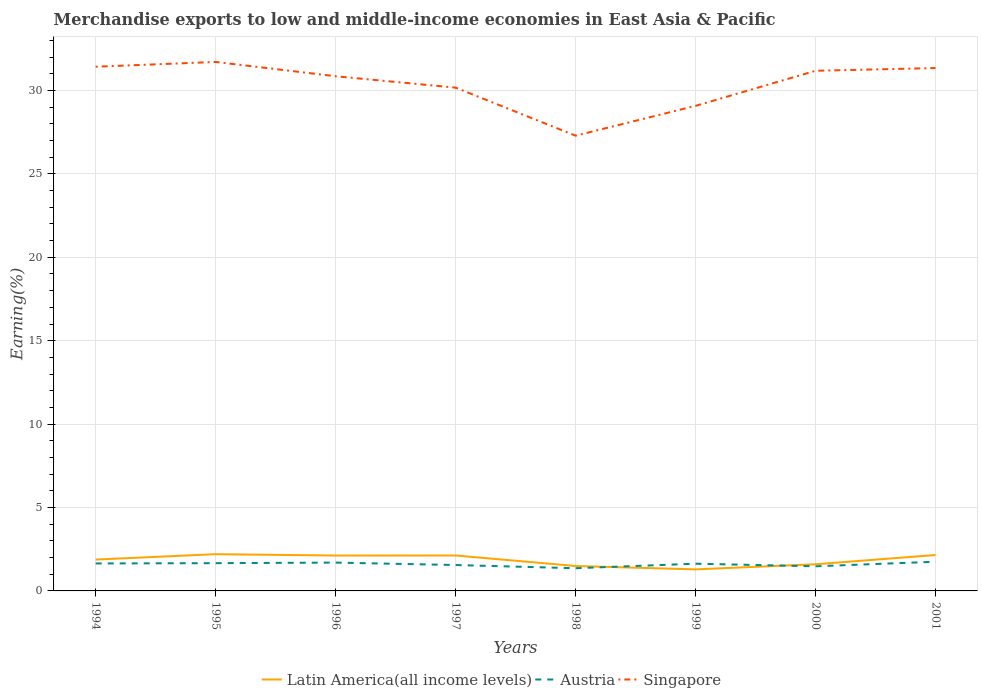How many different coloured lines are there?
Make the answer very short. 3. Does the line corresponding to Singapore intersect with the line corresponding to Austria?
Give a very brief answer. No. Is the number of lines equal to the number of legend labels?
Your response must be concise. Yes. Across all years, what is the maximum percentage of amount earned from merchandise exports in Latin America(all income levels)?
Keep it short and to the point. 1.29. What is the total percentage of amount earned from merchandise exports in Austria in the graph?
Offer a terse response. 0.34. What is the difference between the highest and the second highest percentage of amount earned from merchandise exports in Austria?
Offer a very short reply. 0.39. What is the difference between the highest and the lowest percentage of amount earned from merchandise exports in Latin America(all income levels)?
Offer a terse response. 5. How many lines are there?
Your answer should be compact. 3. How many years are there in the graph?
Ensure brevity in your answer.  8. Does the graph contain grids?
Your response must be concise. Yes. Where does the legend appear in the graph?
Keep it short and to the point. Bottom center. How many legend labels are there?
Make the answer very short. 3. What is the title of the graph?
Keep it short and to the point. Merchandise exports to low and middle-income economies in East Asia & Pacific. Does "Hong Kong" appear as one of the legend labels in the graph?
Offer a very short reply. No. What is the label or title of the Y-axis?
Your answer should be compact. Earning(%). What is the Earning(%) in Latin America(all income levels) in 1994?
Give a very brief answer. 1.88. What is the Earning(%) in Austria in 1994?
Give a very brief answer. 1.65. What is the Earning(%) of Singapore in 1994?
Make the answer very short. 31.42. What is the Earning(%) of Latin America(all income levels) in 1995?
Offer a terse response. 2.2. What is the Earning(%) of Austria in 1995?
Give a very brief answer. 1.66. What is the Earning(%) of Singapore in 1995?
Keep it short and to the point. 31.71. What is the Earning(%) in Latin America(all income levels) in 1996?
Offer a very short reply. 2.12. What is the Earning(%) of Austria in 1996?
Keep it short and to the point. 1.7. What is the Earning(%) of Singapore in 1996?
Your response must be concise. 30.85. What is the Earning(%) in Latin America(all income levels) in 1997?
Offer a terse response. 2.12. What is the Earning(%) of Austria in 1997?
Your response must be concise. 1.55. What is the Earning(%) of Singapore in 1997?
Give a very brief answer. 30.17. What is the Earning(%) in Latin America(all income levels) in 1998?
Offer a very short reply. 1.49. What is the Earning(%) of Austria in 1998?
Provide a succinct answer. 1.36. What is the Earning(%) of Singapore in 1998?
Provide a short and direct response. 27.29. What is the Earning(%) of Latin America(all income levels) in 1999?
Ensure brevity in your answer.  1.29. What is the Earning(%) of Austria in 1999?
Your answer should be compact. 1.63. What is the Earning(%) of Singapore in 1999?
Ensure brevity in your answer.  29.08. What is the Earning(%) in Latin America(all income levels) in 2000?
Make the answer very short. 1.6. What is the Earning(%) in Austria in 2000?
Your answer should be compact. 1.48. What is the Earning(%) in Singapore in 2000?
Your response must be concise. 31.18. What is the Earning(%) of Latin America(all income levels) in 2001?
Provide a succinct answer. 2.15. What is the Earning(%) in Austria in 2001?
Offer a terse response. 1.75. What is the Earning(%) of Singapore in 2001?
Your answer should be compact. 31.34. Across all years, what is the maximum Earning(%) in Latin America(all income levels)?
Give a very brief answer. 2.2. Across all years, what is the maximum Earning(%) of Austria?
Your response must be concise. 1.75. Across all years, what is the maximum Earning(%) in Singapore?
Offer a terse response. 31.71. Across all years, what is the minimum Earning(%) in Latin America(all income levels)?
Provide a succinct answer. 1.29. Across all years, what is the minimum Earning(%) in Austria?
Ensure brevity in your answer.  1.36. Across all years, what is the minimum Earning(%) in Singapore?
Provide a short and direct response. 27.29. What is the total Earning(%) of Latin America(all income levels) in the graph?
Give a very brief answer. 14.86. What is the total Earning(%) of Austria in the graph?
Ensure brevity in your answer.  12.78. What is the total Earning(%) in Singapore in the graph?
Your answer should be compact. 243.04. What is the difference between the Earning(%) of Latin America(all income levels) in 1994 and that in 1995?
Make the answer very short. -0.32. What is the difference between the Earning(%) of Austria in 1994 and that in 1995?
Offer a very short reply. -0.02. What is the difference between the Earning(%) of Singapore in 1994 and that in 1995?
Ensure brevity in your answer.  -0.29. What is the difference between the Earning(%) in Latin America(all income levels) in 1994 and that in 1996?
Ensure brevity in your answer.  -0.24. What is the difference between the Earning(%) in Austria in 1994 and that in 1996?
Give a very brief answer. -0.05. What is the difference between the Earning(%) in Singapore in 1994 and that in 1996?
Give a very brief answer. 0.57. What is the difference between the Earning(%) in Latin America(all income levels) in 1994 and that in 1997?
Keep it short and to the point. -0.24. What is the difference between the Earning(%) in Austria in 1994 and that in 1997?
Provide a short and direct response. 0.09. What is the difference between the Earning(%) in Singapore in 1994 and that in 1997?
Your answer should be compact. 1.25. What is the difference between the Earning(%) in Latin America(all income levels) in 1994 and that in 1998?
Provide a succinct answer. 0.39. What is the difference between the Earning(%) in Austria in 1994 and that in 1998?
Your answer should be compact. 0.29. What is the difference between the Earning(%) in Singapore in 1994 and that in 1998?
Provide a short and direct response. 4.13. What is the difference between the Earning(%) of Latin America(all income levels) in 1994 and that in 1999?
Offer a very short reply. 0.59. What is the difference between the Earning(%) of Austria in 1994 and that in 1999?
Keep it short and to the point. 0.01. What is the difference between the Earning(%) of Singapore in 1994 and that in 1999?
Offer a very short reply. 2.35. What is the difference between the Earning(%) in Latin America(all income levels) in 1994 and that in 2000?
Offer a very short reply. 0.28. What is the difference between the Earning(%) of Austria in 1994 and that in 2000?
Make the answer very short. 0.17. What is the difference between the Earning(%) of Singapore in 1994 and that in 2000?
Offer a very short reply. 0.24. What is the difference between the Earning(%) in Latin America(all income levels) in 1994 and that in 2001?
Offer a very short reply. -0.27. What is the difference between the Earning(%) of Austria in 1994 and that in 2001?
Provide a succinct answer. -0.1. What is the difference between the Earning(%) of Latin America(all income levels) in 1995 and that in 1996?
Provide a succinct answer. 0.08. What is the difference between the Earning(%) in Austria in 1995 and that in 1996?
Provide a succinct answer. -0.03. What is the difference between the Earning(%) of Singapore in 1995 and that in 1996?
Provide a succinct answer. 0.86. What is the difference between the Earning(%) in Latin America(all income levels) in 1995 and that in 1997?
Provide a succinct answer. 0.08. What is the difference between the Earning(%) in Austria in 1995 and that in 1997?
Provide a succinct answer. 0.11. What is the difference between the Earning(%) in Singapore in 1995 and that in 1997?
Your answer should be very brief. 1.54. What is the difference between the Earning(%) in Latin America(all income levels) in 1995 and that in 1998?
Make the answer very short. 0.71. What is the difference between the Earning(%) of Austria in 1995 and that in 1998?
Provide a short and direct response. 0.3. What is the difference between the Earning(%) in Singapore in 1995 and that in 1998?
Offer a very short reply. 4.42. What is the difference between the Earning(%) of Latin America(all income levels) in 1995 and that in 1999?
Provide a short and direct response. 0.91. What is the difference between the Earning(%) of Austria in 1995 and that in 1999?
Offer a terse response. 0.03. What is the difference between the Earning(%) in Singapore in 1995 and that in 1999?
Your answer should be compact. 2.63. What is the difference between the Earning(%) in Latin America(all income levels) in 1995 and that in 2000?
Provide a succinct answer. 0.6. What is the difference between the Earning(%) of Austria in 1995 and that in 2000?
Give a very brief answer. 0.19. What is the difference between the Earning(%) of Singapore in 1995 and that in 2000?
Keep it short and to the point. 0.53. What is the difference between the Earning(%) in Latin America(all income levels) in 1995 and that in 2001?
Your response must be concise. 0.05. What is the difference between the Earning(%) in Austria in 1995 and that in 2001?
Provide a succinct answer. -0.09. What is the difference between the Earning(%) in Singapore in 1995 and that in 2001?
Keep it short and to the point. 0.37. What is the difference between the Earning(%) in Latin America(all income levels) in 1996 and that in 1997?
Offer a terse response. -0. What is the difference between the Earning(%) of Austria in 1996 and that in 1997?
Offer a terse response. 0.15. What is the difference between the Earning(%) of Singapore in 1996 and that in 1997?
Offer a terse response. 0.68. What is the difference between the Earning(%) in Latin America(all income levels) in 1996 and that in 1998?
Give a very brief answer. 0.63. What is the difference between the Earning(%) of Austria in 1996 and that in 1998?
Provide a short and direct response. 0.34. What is the difference between the Earning(%) in Singapore in 1996 and that in 1998?
Offer a very short reply. 3.56. What is the difference between the Earning(%) in Latin America(all income levels) in 1996 and that in 1999?
Your answer should be very brief. 0.83. What is the difference between the Earning(%) of Austria in 1996 and that in 1999?
Your answer should be very brief. 0.07. What is the difference between the Earning(%) of Singapore in 1996 and that in 1999?
Offer a very short reply. 1.77. What is the difference between the Earning(%) in Latin America(all income levels) in 1996 and that in 2000?
Your response must be concise. 0.52. What is the difference between the Earning(%) in Austria in 1996 and that in 2000?
Give a very brief answer. 0.22. What is the difference between the Earning(%) in Singapore in 1996 and that in 2000?
Keep it short and to the point. -0.33. What is the difference between the Earning(%) of Latin America(all income levels) in 1996 and that in 2001?
Ensure brevity in your answer.  -0.03. What is the difference between the Earning(%) in Austria in 1996 and that in 2001?
Your answer should be compact. -0.05. What is the difference between the Earning(%) in Singapore in 1996 and that in 2001?
Offer a terse response. -0.49. What is the difference between the Earning(%) in Latin America(all income levels) in 1997 and that in 1998?
Offer a very short reply. 0.63. What is the difference between the Earning(%) in Austria in 1997 and that in 1998?
Provide a succinct answer. 0.19. What is the difference between the Earning(%) of Singapore in 1997 and that in 1998?
Provide a succinct answer. 2.88. What is the difference between the Earning(%) in Latin America(all income levels) in 1997 and that in 1999?
Give a very brief answer. 0.83. What is the difference between the Earning(%) in Austria in 1997 and that in 1999?
Provide a short and direct response. -0.08. What is the difference between the Earning(%) in Singapore in 1997 and that in 1999?
Your answer should be very brief. 1.09. What is the difference between the Earning(%) of Latin America(all income levels) in 1997 and that in 2000?
Offer a terse response. 0.53. What is the difference between the Earning(%) of Austria in 1997 and that in 2000?
Your response must be concise. 0.08. What is the difference between the Earning(%) in Singapore in 1997 and that in 2000?
Make the answer very short. -1.01. What is the difference between the Earning(%) of Latin America(all income levels) in 1997 and that in 2001?
Keep it short and to the point. -0.03. What is the difference between the Earning(%) in Austria in 1997 and that in 2001?
Your answer should be compact. -0.2. What is the difference between the Earning(%) of Singapore in 1997 and that in 2001?
Ensure brevity in your answer.  -1.17. What is the difference between the Earning(%) in Latin America(all income levels) in 1998 and that in 1999?
Give a very brief answer. 0.2. What is the difference between the Earning(%) of Austria in 1998 and that in 1999?
Offer a very short reply. -0.27. What is the difference between the Earning(%) in Singapore in 1998 and that in 1999?
Make the answer very short. -1.79. What is the difference between the Earning(%) of Latin America(all income levels) in 1998 and that in 2000?
Give a very brief answer. -0.11. What is the difference between the Earning(%) in Austria in 1998 and that in 2000?
Your response must be concise. -0.12. What is the difference between the Earning(%) of Singapore in 1998 and that in 2000?
Your answer should be very brief. -3.89. What is the difference between the Earning(%) of Latin America(all income levels) in 1998 and that in 2001?
Make the answer very short. -0.66. What is the difference between the Earning(%) of Austria in 1998 and that in 2001?
Make the answer very short. -0.39. What is the difference between the Earning(%) in Singapore in 1998 and that in 2001?
Your response must be concise. -4.05. What is the difference between the Earning(%) in Latin America(all income levels) in 1999 and that in 2000?
Your answer should be compact. -0.31. What is the difference between the Earning(%) in Austria in 1999 and that in 2000?
Your answer should be compact. 0.16. What is the difference between the Earning(%) of Singapore in 1999 and that in 2000?
Your answer should be very brief. -2.1. What is the difference between the Earning(%) in Latin America(all income levels) in 1999 and that in 2001?
Your answer should be very brief. -0.86. What is the difference between the Earning(%) of Austria in 1999 and that in 2001?
Offer a very short reply. -0.12. What is the difference between the Earning(%) of Singapore in 1999 and that in 2001?
Give a very brief answer. -2.27. What is the difference between the Earning(%) of Latin America(all income levels) in 2000 and that in 2001?
Your answer should be very brief. -0.55. What is the difference between the Earning(%) in Austria in 2000 and that in 2001?
Give a very brief answer. -0.27. What is the difference between the Earning(%) of Singapore in 2000 and that in 2001?
Keep it short and to the point. -0.16. What is the difference between the Earning(%) of Latin America(all income levels) in 1994 and the Earning(%) of Austria in 1995?
Make the answer very short. 0.22. What is the difference between the Earning(%) of Latin America(all income levels) in 1994 and the Earning(%) of Singapore in 1995?
Your response must be concise. -29.83. What is the difference between the Earning(%) of Austria in 1994 and the Earning(%) of Singapore in 1995?
Keep it short and to the point. -30.06. What is the difference between the Earning(%) in Latin America(all income levels) in 1994 and the Earning(%) in Austria in 1996?
Keep it short and to the point. 0.18. What is the difference between the Earning(%) of Latin America(all income levels) in 1994 and the Earning(%) of Singapore in 1996?
Offer a very short reply. -28.97. What is the difference between the Earning(%) in Austria in 1994 and the Earning(%) in Singapore in 1996?
Your answer should be compact. -29.2. What is the difference between the Earning(%) in Latin America(all income levels) in 1994 and the Earning(%) in Austria in 1997?
Make the answer very short. 0.33. What is the difference between the Earning(%) of Latin America(all income levels) in 1994 and the Earning(%) of Singapore in 1997?
Give a very brief answer. -28.29. What is the difference between the Earning(%) of Austria in 1994 and the Earning(%) of Singapore in 1997?
Ensure brevity in your answer.  -28.52. What is the difference between the Earning(%) of Latin America(all income levels) in 1994 and the Earning(%) of Austria in 1998?
Make the answer very short. 0.52. What is the difference between the Earning(%) in Latin America(all income levels) in 1994 and the Earning(%) in Singapore in 1998?
Offer a very short reply. -25.41. What is the difference between the Earning(%) of Austria in 1994 and the Earning(%) of Singapore in 1998?
Offer a terse response. -25.64. What is the difference between the Earning(%) in Latin America(all income levels) in 1994 and the Earning(%) in Austria in 1999?
Your response must be concise. 0.25. What is the difference between the Earning(%) in Latin America(all income levels) in 1994 and the Earning(%) in Singapore in 1999?
Make the answer very short. -27.2. What is the difference between the Earning(%) in Austria in 1994 and the Earning(%) in Singapore in 1999?
Provide a short and direct response. -27.43. What is the difference between the Earning(%) in Latin America(all income levels) in 1994 and the Earning(%) in Austria in 2000?
Offer a terse response. 0.4. What is the difference between the Earning(%) of Latin America(all income levels) in 1994 and the Earning(%) of Singapore in 2000?
Make the answer very short. -29.3. What is the difference between the Earning(%) in Austria in 1994 and the Earning(%) in Singapore in 2000?
Offer a very short reply. -29.53. What is the difference between the Earning(%) in Latin America(all income levels) in 1994 and the Earning(%) in Austria in 2001?
Offer a very short reply. 0.13. What is the difference between the Earning(%) in Latin America(all income levels) in 1994 and the Earning(%) in Singapore in 2001?
Your answer should be compact. -29.46. What is the difference between the Earning(%) of Austria in 1994 and the Earning(%) of Singapore in 2001?
Provide a succinct answer. -29.7. What is the difference between the Earning(%) in Latin America(all income levels) in 1995 and the Earning(%) in Austria in 1996?
Your answer should be compact. 0.5. What is the difference between the Earning(%) in Latin America(all income levels) in 1995 and the Earning(%) in Singapore in 1996?
Provide a short and direct response. -28.65. What is the difference between the Earning(%) of Austria in 1995 and the Earning(%) of Singapore in 1996?
Provide a short and direct response. -29.19. What is the difference between the Earning(%) of Latin America(all income levels) in 1995 and the Earning(%) of Austria in 1997?
Offer a terse response. 0.65. What is the difference between the Earning(%) of Latin America(all income levels) in 1995 and the Earning(%) of Singapore in 1997?
Your response must be concise. -27.97. What is the difference between the Earning(%) of Austria in 1995 and the Earning(%) of Singapore in 1997?
Make the answer very short. -28.5. What is the difference between the Earning(%) of Latin America(all income levels) in 1995 and the Earning(%) of Austria in 1998?
Your response must be concise. 0.84. What is the difference between the Earning(%) of Latin America(all income levels) in 1995 and the Earning(%) of Singapore in 1998?
Provide a succinct answer. -25.09. What is the difference between the Earning(%) of Austria in 1995 and the Earning(%) of Singapore in 1998?
Your answer should be compact. -25.62. What is the difference between the Earning(%) in Latin America(all income levels) in 1995 and the Earning(%) in Austria in 1999?
Keep it short and to the point. 0.57. What is the difference between the Earning(%) of Latin America(all income levels) in 1995 and the Earning(%) of Singapore in 1999?
Ensure brevity in your answer.  -26.87. What is the difference between the Earning(%) of Austria in 1995 and the Earning(%) of Singapore in 1999?
Provide a short and direct response. -27.41. What is the difference between the Earning(%) of Latin America(all income levels) in 1995 and the Earning(%) of Austria in 2000?
Keep it short and to the point. 0.73. What is the difference between the Earning(%) in Latin America(all income levels) in 1995 and the Earning(%) in Singapore in 2000?
Provide a succinct answer. -28.98. What is the difference between the Earning(%) of Austria in 1995 and the Earning(%) of Singapore in 2000?
Ensure brevity in your answer.  -29.52. What is the difference between the Earning(%) in Latin America(all income levels) in 1995 and the Earning(%) in Austria in 2001?
Your response must be concise. 0.45. What is the difference between the Earning(%) in Latin America(all income levels) in 1995 and the Earning(%) in Singapore in 2001?
Provide a short and direct response. -29.14. What is the difference between the Earning(%) in Austria in 1995 and the Earning(%) in Singapore in 2001?
Keep it short and to the point. -29.68. What is the difference between the Earning(%) in Latin America(all income levels) in 1996 and the Earning(%) in Austria in 1997?
Offer a terse response. 0.57. What is the difference between the Earning(%) of Latin America(all income levels) in 1996 and the Earning(%) of Singapore in 1997?
Your answer should be very brief. -28.05. What is the difference between the Earning(%) of Austria in 1996 and the Earning(%) of Singapore in 1997?
Your answer should be very brief. -28.47. What is the difference between the Earning(%) of Latin America(all income levels) in 1996 and the Earning(%) of Austria in 1998?
Keep it short and to the point. 0.76. What is the difference between the Earning(%) of Latin America(all income levels) in 1996 and the Earning(%) of Singapore in 1998?
Give a very brief answer. -25.17. What is the difference between the Earning(%) in Austria in 1996 and the Earning(%) in Singapore in 1998?
Provide a short and direct response. -25.59. What is the difference between the Earning(%) of Latin America(all income levels) in 1996 and the Earning(%) of Austria in 1999?
Provide a short and direct response. 0.49. What is the difference between the Earning(%) of Latin America(all income levels) in 1996 and the Earning(%) of Singapore in 1999?
Give a very brief answer. -26.95. What is the difference between the Earning(%) in Austria in 1996 and the Earning(%) in Singapore in 1999?
Offer a very short reply. -27.38. What is the difference between the Earning(%) in Latin America(all income levels) in 1996 and the Earning(%) in Austria in 2000?
Your response must be concise. 0.65. What is the difference between the Earning(%) of Latin America(all income levels) in 1996 and the Earning(%) of Singapore in 2000?
Your response must be concise. -29.06. What is the difference between the Earning(%) of Austria in 1996 and the Earning(%) of Singapore in 2000?
Your answer should be compact. -29.48. What is the difference between the Earning(%) of Latin America(all income levels) in 1996 and the Earning(%) of Austria in 2001?
Ensure brevity in your answer.  0.37. What is the difference between the Earning(%) in Latin America(all income levels) in 1996 and the Earning(%) in Singapore in 2001?
Your answer should be very brief. -29.22. What is the difference between the Earning(%) of Austria in 1996 and the Earning(%) of Singapore in 2001?
Provide a succinct answer. -29.64. What is the difference between the Earning(%) of Latin America(all income levels) in 1997 and the Earning(%) of Austria in 1998?
Keep it short and to the point. 0.76. What is the difference between the Earning(%) of Latin America(all income levels) in 1997 and the Earning(%) of Singapore in 1998?
Provide a short and direct response. -25.16. What is the difference between the Earning(%) in Austria in 1997 and the Earning(%) in Singapore in 1998?
Keep it short and to the point. -25.74. What is the difference between the Earning(%) of Latin America(all income levels) in 1997 and the Earning(%) of Austria in 1999?
Keep it short and to the point. 0.49. What is the difference between the Earning(%) of Latin America(all income levels) in 1997 and the Earning(%) of Singapore in 1999?
Your answer should be very brief. -26.95. What is the difference between the Earning(%) in Austria in 1997 and the Earning(%) in Singapore in 1999?
Offer a very short reply. -27.52. What is the difference between the Earning(%) in Latin America(all income levels) in 1997 and the Earning(%) in Austria in 2000?
Your answer should be very brief. 0.65. What is the difference between the Earning(%) in Latin America(all income levels) in 1997 and the Earning(%) in Singapore in 2000?
Your response must be concise. -29.05. What is the difference between the Earning(%) in Austria in 1997 and the Earning(%) in Singapore in 2000?
Your answer should be compact. -29.63. What is the difference between the Earning(%) of Latin America(all income levels) in 1997 and the Earning(%) of Austria in 2001?
Make the answer very short. 0.37. What is the difference between the Earning(%) in Latin America(all income levels) in 1997 and the Earning(%) in Singapore in 2001?
Ensure brevity in your answer.  -29.22. What is the difference between the Earning(%) of Austria in 1997 and the Earning(%) of Singapore in 2001?
Make the answer very short. -29.79. What is the difference between the Earning(%) in Latin America(all income levels) in 1998 and the Earning(%) in Austria in 1999?
Your answer should be compact. -0.14. What is the difference between the Earning(%) in Latin America(all income levels) in 1998 and the Earning(%) in Singapore in 1999?
Make the answer very short. -27.58. What is the difference between the Earning(%) in Austria in 1998 and the Earning(%) in Singapore in 1999?
Offer a terse response. -27.72. What is the difference between the Earning(%) in Latin America(all income levels) in 1998 and the Earning(%) in Austria in 2000?
Provide a short and direct response. 0.02. What is the difference between the Earning(%) in Latin America(all income levels) in 1998 and the Earning(%) in Singapore in 2000?
Offer a terse response. -29.69. What is the difference between the Earning(%) in Austria in 1998 and the Earning(%) in Singapore in 2000?
Your answer should be compact. -29.82. What is the difference between the Earning(%) in Latin America(all income levels) in 1998 and the Earning(%) in Austria in 2001?
Provide a succinct answer. -0.26. What is the difference between the Earning(%) of Latin America(all income levels) in 1998 and the Earning(%) of Singapore in 2001?
Offer a very short reply. -29.85. What is the difference between the Earning(%) in Austria in 1998 and the Earning(%) in Singapore in 2001?
Offer a terse response. -29.98. What is the difference between the Earning(%) of Latin America(all income levels) in 1999 and the Earning(%) of Austria in 2000?
Provide a succinct answer. -0.18. What is the difference between the Earning(%) in Latin America(all income levels) in 1999 and the Earning(%) in Singapore in 2000?
Make the answer very short. -29.89. What is the difference between the Earning(%) of Austria in 1999 and the Earning(%) of Singapore in 2000?
Your response must be concise. -29.55. What is the difference between the Earning(%) in Latin America(all income levels) in 1999 and the Earning(%) in Austria in 2001?
Offer a terse response. -0.46. What is the difference between the Earning(%) in Latin America(all income levels) in 1999 and the Earning(%) in Singapore in 2001?
Provide a short and direct response. -30.05. What is the difference between the Earning(%) of Austria in 1999 and the Earning(%) of Singapore in 2001?
Your response must be concise. -29.71. What is the difference between the Earning(%) in Latin America(all income levels) in 2000 and the Earning(%) in Austria in 2001?
Offer a very short reply. -0.15. What is the difference between the Earning(%) of Latin America(all income levels) in 2000 and the Earning(%) of Singapore in 2001?
Your answer should be very brief. -29.75. What is the difference between the Earning(%) of Austria in 2000 and the Earning(%) of Singapore in 2001?
Your answer should be compact. -29.87. What is the average Earning(%) in Latin America(all income levels) per year?
Your answer should be compact. 1.86. What is the average Earning(%) in Austria per year?
Keep it short and to the point. 1.6. What is the average Earning(%) of Singapore per year?
Your answer should be compact. 30.38. In the year 1994, what is the difference between the Earning(%) of Latin America(all income levels) and Earning(%) of Austria?
Keep it short and to the point. 0.23. In the year 1994, what is the difference between the Earning(%) in Latin America(all income levels) and Earning(%) in Singapore?
Offer a terse response. -29.54. In the year 1994, what is the difference between the Earning(%) of Austria and Earning(%) of Singapore?
Offer a terse response. -29.78. In the year 1995, what is the difference between the Earning(%) of Latin America(all income levels) and Earning(%) of Austria?
Offer a very short reply. 0.54. In the year 1995, what is the difference between the Earning(%) in Latin America(all income levels) and Earning(%) in Singapore?
Offer a very short reply. -29.51. In the year 1995, what is the difference between the Earning(%) in Austria and Earning(%) in Singapore?
Your answer should be very brief. -30.04. In the year 1996, what is the difference between the Earning(%) in Latin America(all income levels) and Earning(%) in Austria?
Offer a very short reply. 0.42. In the year 1996, what is the difference between the Earning(%) in Latin America(all income levels) and Earning(%) in Singapore?
Offer a very short reply. -28.73. In the year 1996, what is the difference between the Earning(%) of Austria and Earning(%) of Singapore?
Make the answer very short. -29.15. In the year 1997, what is the difference between the Earning(%) of Latin America(all income levels) and Earning(%) of Austria?
Give a very brief answer. 0.57. In the year 1997, what is the difference between the Earning(%) in Latin America(all income levels) and Earning(%) in Singapore?
Ensure brevity in your answer.  -28.04. In the year 1997, what is the difference between the Earning(%) in Austria and Earning(%) in Singapore?
Make the answer very short. -28.62. In the year 1998, what is the difference between the Earning(%) in Latin America(all income levels) and Earning(%) in Austria?
Make the answer very short. 0.13. In the year 1998, what is the difference between the Earning(%) of Latin America(all income levels) and Earning(%) of Singapore?
Keep it short and to the point. -25.8. In the year 1998, what is the difference between the Earning(%) in Austria and Earning(%) in Singapore?
Give a very brief answer. -25.93. In the year 1999, what is the difference between the Earning(%) in Latin America(all income levels) and Earning(%) in Austria?
Keep it short and to the point. -0.34. In the year 1999, what is the difference between the Earning(%) of Latin America(all income levels) and Earning(%) of Singapore?
Ensure brevity in your answer.  -27.78. In the year 1999, what is the difference between the Earning(%) of Austria and Earning(%) of Singapore?
Keep it short and to the point. -27.44. In the year 2000, what is the difference between the Earning(%) of Latin America(all income levels) and Earning(%) of Austria?
Offer a terse response. 0.12. In the year 2000, what is the difference between the Earning(%) of Latin America(all income levels) and Earning(%) of Singapore?
Offer a very short reply. -29.58. In the year 2000, what is the difference between the Earning(%) in Austria and Earning(%) in Singapore?
Make the answer very short. -29.7. In the year 2001, what is the difference between the Earning(%) in Latin America(all income levels) and Earning(%) in Austria?
Your answer should be very brief. 0.4. In the year 2001, what is the difference between the Earning(%) of Latin America(all income levels) and Earning(%) of Singapore?
Your answer should be compact. -29.19. In the year 2001, what is the difference between the Earning(%) of Austria and Earning(%) of Singapore?
Offer a very short reply. -29.59. What is the ratio of the Earning(%) of Latin America(all income levels) in 1994 to that in 1995?
Your answer should be very brief. 0.85. What is the ratio of the Earning(%) in Latin America(all income levels) in 1994 to that in 1996?
Your response must be concise. 0.89. What is the ratio of the Earning(%) of Austria in 1994 to that in 1996?
Give a very brief answer. 0.97. What is the ratio of the Earning(%) in Singapore in 1994 to that in 1996?
Keep it short and to the point. 1.02. What is the ratio of the Earning(%) of Latin America(all income levels) in 1994 to that in 1997?
Offer a terse response. 0.89. What is the ratio of the Earning(%) in Austria in 1994 to that in 1997?
Your response must be concise. 1.06. What is the ratio of the Earning(%) of Singapore in 1994 to that in 1997?
Provide a succinct answer. 1.04. What is the ratio of the Earning(%) in Latin America(all income levels) in 1994 to that in 1998?
Make the answer very short. 1.26. What is the ratio of the Earning(%) of Austria in 1994 to that in 1998?
Your answer should be compact. 1.21. What is the ratio of the Earning(%) of Singapore in 1994 to that in 1998?
Offer a terse response. 1.15. What is the ratio of the Earning(%) in Latin America(all income levels) in 1994 to that in 1999?
Provide a succinct answer. 1.46. What is the ratio of the Earning(%) of Austria in 1994 to that in 1999?
Give a very brief answer. 1.01. What is the ratio of the Earning(%) of Singapore in 1994 to that in 1999?
Offer a terse response. 1.08. What is the ratio of the Earning(%) of Latin America(all income levels) in 1994 to that in 2000?
Your answer should be very brief. 1.18. What is the ratio of the Earning(%) in Austria in 1994 to that in 2000?
Your answer should be compact. 1.12. What is the ratio of the Earning(%) of Latin America(all income levels) in 1994 to that in 2001?
Your answer should be compact. 0.87. What is the ratio of the Earning(%) in Austria in 1994 to that in 2001?
Your answer should be very brief. 0.94. What is the ratio of the Earning(%) in Singapore in 1994 to that in 2001?
Make the answer very short. 1. What is the ratio of the Earning(%) in Latin America(all income levels) in 1995 to that in 1996?
Keep it short and to the point. 1.04. What is the ratio of the Earning(%) of Austria in 1995 to that in 1996?
Give a very brief answer. 0.98. What is the ratio of the Earning(%) of Singapore in 1995 to that in 1996?
Offer a terse response. 1.03. What is the ratio of the Earning(%) in Latin America(all income levels) in 1995 to that in 1997?
Offer a very short reply. 1.04. What is the ratio of the Earning(%) in Austria in 1995 to that in 1997?
Your answer should be compact. 1.07. What is the ratio of the Earning(%) of Singapore in 1995 to that in 1997?
Keep it short and to the point. 1.05. What is the ratio of the Earning(%) in Latin America(all income levels) in 1995 to that in 1998?
Ensure brevity in your answer.  1.48. What is the ratio of the Earning(%) in Austria in 1995 to that in 1998?
Offer a very short reply. 1.22. What is the ratio of the Earning(%) in Singapore in 1995 to that in 1998?
Your answer should be very brief. 1.16. What is the ratio of the Earning(%) in Latin America(all income levels) in 1995 to that in 1999?
Offer a very short reply. 1.7. What is the ratio of the Earning(%) of Austria in 1995 to that in 1999?
Make the answer very short. 1.02. What is the ratio of the Earning(%) in Singapore in 1995 to that in 1999?
Offer a very short reply. 1.09. What is the ratio of the Earning(%) of Latin America(all income levels) in 1995 to that in 2000?
Offer a very short reply. 1.38. What is the ratio of the Earning(%) in Austria in 1995 to that in 2000?
Offer a very short reply. 1.13. What is the ratio of the Earning(%) in Latin America(all income levels) in 1995 to that in 2001?
Your answer should be compact. 1.02. What is the ratio of the Earning(%) of Austria in 1995 to that in 2001?
Provide a short and direct response. 0.95. What is the ratio of the Earning(%) in Singapore in 1995 to that in 2001?
Keep it short and to the point. 1.01. What is the ratio of the Earning(%) in Latin America(all income levels) in 1996 to that in 1997?
Offer a terse response. 1. What is the ratio of the Earning(%) in Austria in 1996 to that in 1997?
Offer a terse response. 1.09. What is the ratio of the Earning(%) of Singapore in 1996 to that in 1997?
Offer a terse response. 1.02. What is the ratio of the Earning(%) in Latin America(all income levels) in 1996 to that in 1998?
Ensure brevity in your answer.  1.42. What is the ratio of the Earning(%) in Austria in 1996 to that in 1998?
Your response must be concise. 1.25. What is the ratio of the Earning(%) in Singapore in 1996 to that in 1998?
Your response must be concise. 1.13. What is the ratio of the Earning(%) in Latin America(all income levels) in 1996 to that in 1999?
Make the answer very short. 1.64. What is the ratio of the Earning(%) in Austria in 1996 to that in 1999?
Provide a succinct answer. 1.04. What is the ratio of the Earning(%) in Singapore in 1996 to that in 1999?
Ensure brevity in your answer.  1.06. What is the ratio of the Earning(%) in Latin America(all income levels) in 1996 to that in 2000?
Offer a terse response. 1.33. What is the ratio of the Earning(%) of Austria in 1996 to that in 2000?
Keep it short and to the point. 1.15. What is the ratio of the Earning(%) in Latin America(all income levels) in 1996 to that in 2001?
Keep it short and to the point. 0.99. What is the ratio of the Earning(%) of Austria in 1996 to that in 2001?
Provide a succinct answer. 0.97. What is the ratio of the Earning(%) in Singapore in 1996 to that in 2001?
Your response must be concise. 0.98. What is the ratio of the Earning(%) in Latin America(all income levels) in 1997 to that in 1998?
Your answer should be compact. 1.42. What is the ratio of the Earning(%) of Austria in 1997 to that in 1998?
Keep it short and to the point. 1.14. What is the ratio of the Earning(%) in Singapore in 1997 to that in 1998?
Your response must be concise. 1.11. What is the ratio of the Earning(%) in Latin America(all income levels) in 1997 to that in 1999?
Offer a terse response. 1.64. What is the ratio of the Earning(%) in Austria in 1997 to that in 1999?
Your response must be concise. 0.95. What is the ratio of the Earning(%) in Singapore in 1997 to that in 1999?
Keep it short and to the point. 1.04. What is the ratio of the Earning(%) of Latin America(all income levels) in 1997 to that in 2000?
Your answer should be compact. 1.33. What is the ratio of the Earning(%) of Austria in 1997 to that in 2000?
Give a very brief answer. 1.05. What is the ratio of the Earning(%) in Singapore in 1997 to that in 2000?
Make the answer very short. 0.97. What is the ratio of the Earning(%) in Austria in 1997 to that in 2001?
Your response must be concise. 0.89. What is the ratio of the Earning(%) of Singapore in 1997 to that in 2001?
Offer a very short reply. 0.96. What is the ratio of the Earning(%) of Latin America(all income levels) in 1998 to that in 1999?
Keep it short and to the point. 1.16. What is the ratio of the Earning(%) in Austria in 1998 to that in 1999?
Ensure brevity in your answer.  0.83. What is the ratio of the Earning(%) in Singapore in 1998 to that in 1999?
Your answer should be very brief. 0.94. What is the ratio of the Earning(%) of Latin America(all income levels) in 1998 to that in 2000?
Give a very brief answer. 0.93. What is the ratio of the Earning(%) in Austria in 1998 to that in 2000?
Your answer should be compact. 0.92. What is the ratio of the Earning(%) of Singapore in 1998 to that in 2000?
Offer a terse response. 0.88. What is the ratio of the Earning(%) of Latin America(all income levels) in 1998 to that in 2001?
Provide a short and direct response. 0.69. What is the ratio of the Earning(%) of Austria in 1998 to that in 2001?
Your response must be concise. 0.78. What is the ratio of the Earning(%) of Singapore in 1998 to that in 2001?
Give a very brief answer. 0.87. What is the ratio of the Earning(%) in Latin America(all income levels) in 1999 to that in 2000?
Your response must be concise. 0.81. What is the ratio of the Earning(%) in Austria in 1999 to that in 2000?
Provide a short and direct response. 1.11. What is the ratio of the Earning(%) in Singapore in 1999 to that in 2000?
Provide a short and direct response. 0.93. What is the ratio of the Earning(%) in Latin America(all income levels) in 1999 to that in 2001?
Your answer should be compact. 0.6. What is the ratio of the Earning(%) of Austria in 1999 to that in 2001?
Make the answer very short. 0.93. What is the ratio of the Earning(%) in Singapore in 1999 to that in 2001?
Your answer should be compact. 0.93. What is the ratio of the Earning(%) of Latin America(all income levels) in 2000 to that in 2001?
Keep it short and to the point. 0.74. What is the ratio of the Earning(%) of Austria in 2000 to that in 2001?
Offer a terse response. 0.84. What is the ratio of the Earning(%) in Singapore in 2000 to that in 2001?
Your response must be concise. 0.99. What is the difference between the highest and the second highest Earning(%) in Latin America(all income levels)?
Your answer should be compact. 0.05. What is the difference between the highest and the second highest Earning(%) of Austria?
Provide a short and direct response. 0.05. What is the difference between the highest and the second highest Earning(%) in Singapore?
Your response must be concise. 0.29. What is the difference between the highest and the lowest Earning(%) of Latin America(all income levels)?
Make the answer very short. 0.91. What is the difference between the highest and the lowest Earning(%) in Austria?
Your response must be concise. 0.39. What is the difference between the highest and the lowest Earning(%) in Singapore?
Ensure brevity in your answer.  4.42. 